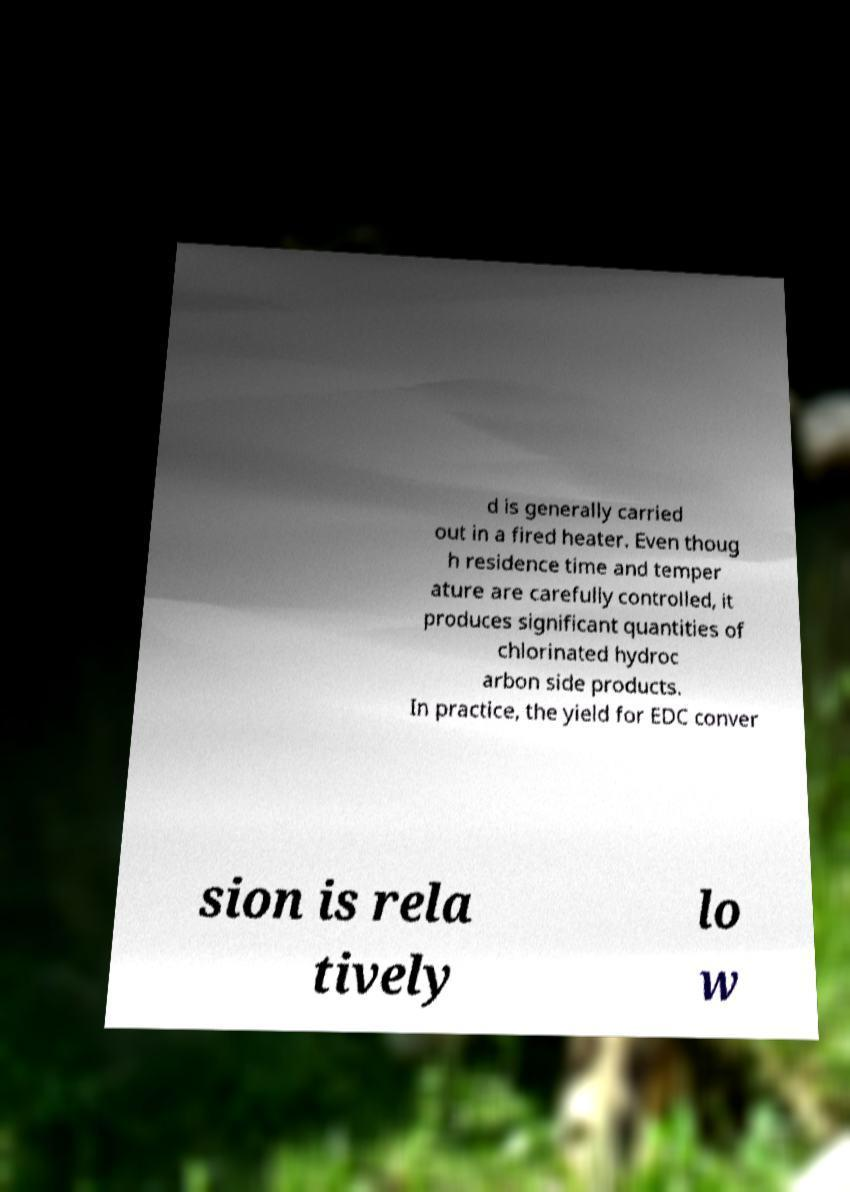For documentation purposes, I need the text within this image transcribed. Could you provide that? d is generally carried out in a fired heater. Even thoug h residence time and temper ature are carefully controlled, it produces significant quantities of chlorinated hydroc arbon side products. In practice, the yield for EDC conver sion is rela tively lo w 